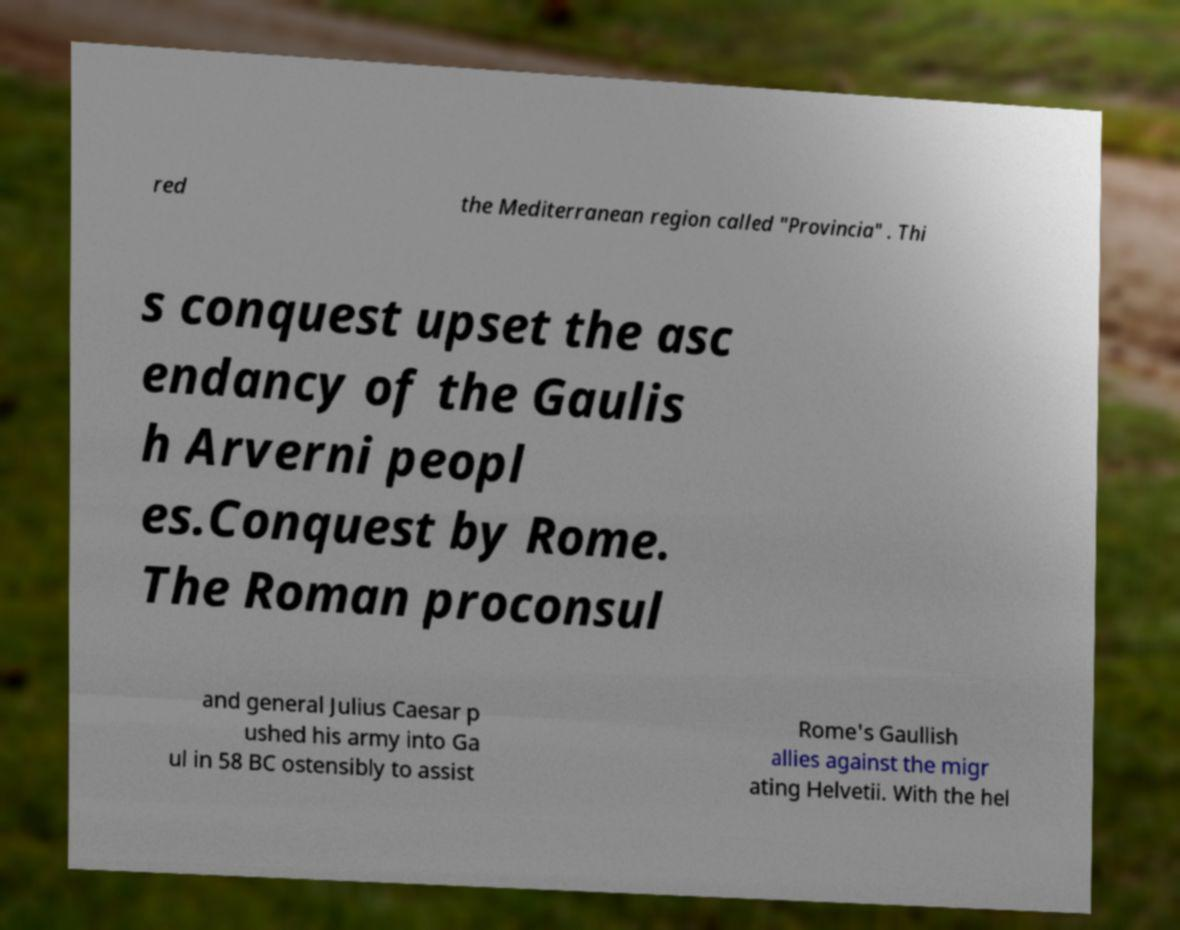What messages or text are displayed in this image? I need them in a readable, typed format. red the Mediterranean region called "Provincia" . Thi s conquest upset the asc endancy of the Gaulis h Arverni peopl es.Conquest by Rome. The Roman proconsul and general Julius Caesar p ushed his army into Ga ul in 58 BC ostensibly to assist Rome's Gaullish allies against the migr ating Helvetii. With the hel 